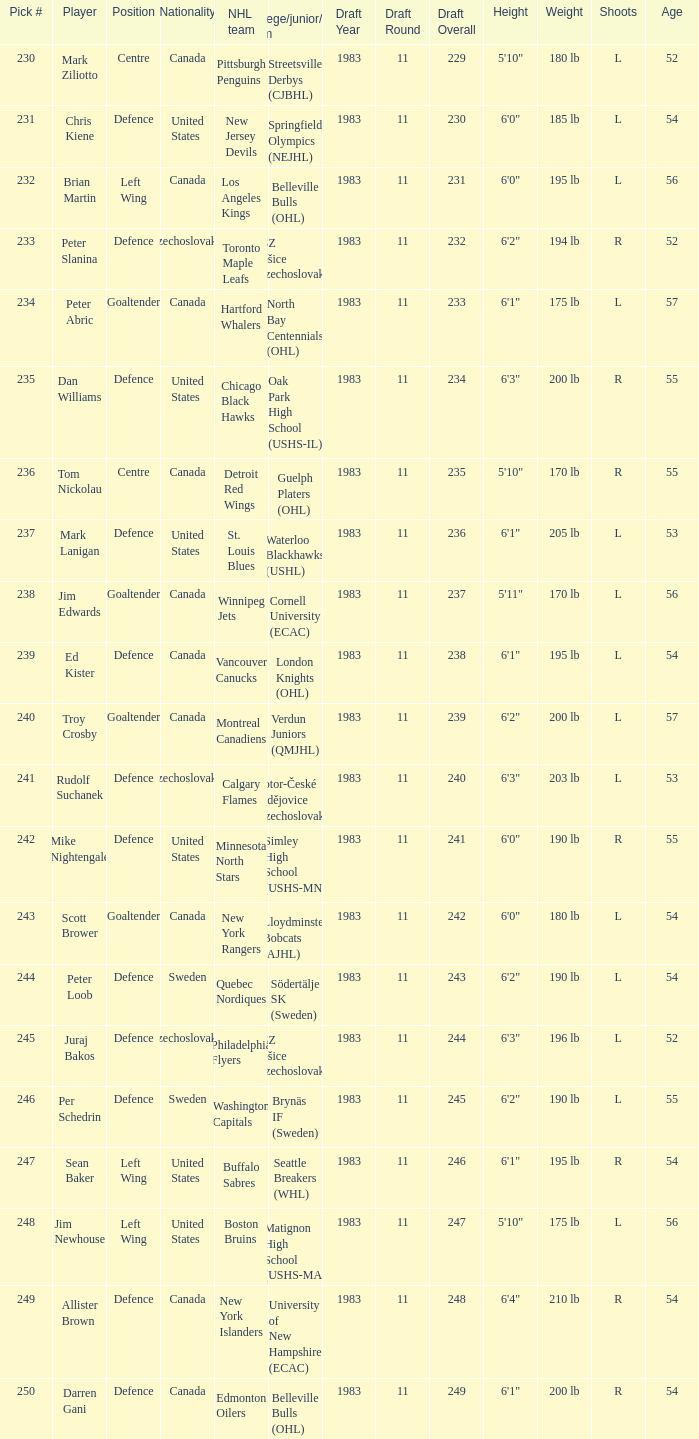Parse the full table. {'header': ['Pick #', 'Player', 'Position', 'Nationality', 'NHL team', 'College/junior/club team', 'Draft Year', 'Draft Round', 'Draft Overall', 'Height', 'Weight', 'Shoots', 'Age'], 'rows': [['230', 'Mark Ziliotto', 'Centre', 'Canada', 'Pittsburgh Penguins', 'Streetsville Derbys (CJBHL)', '1983', '11', '229', '5\'10"', '180 lb', 'L', '52'], ['231', 'Chris Kiene', 'Defence', 'United States', 'New Jersey Devils', 'Springfield Olympics (NEJHL)', '1983', '11', '230', '6\'0"', '185 lb', 'L', '54'], ['232', 'Brian Martin', 'Left Wing', 'Canada', 'Los Angeles Kings', 'Belleville Bulls (OHL)', '1983', '11', '231', '6\'0"', '195 lb', 'L', '56'], ['233', 'Peter Slanina', 'Defence', 'Czechoslovakia', 'Toronto Maple Leafs', 'VSZ Košice (Czechoslovakia)', '1983', '11', '232', '6\'2"', '194 lb', 'R', '52'], ['234', 'Peter Abric', 'Goaltender', 'Canada', 'Hartford Whalers', 'North Bay Centennials (OHL)', '1983', '11', '233', '6\'1"', '175 lb', 'L', '57'], ['235', 'Dan Williams', 'Defence', 'United States', 'Chicago Black Hawks', 'Oak Park High School (USHS-IL)', '1983', '11', '234', '6\'3"', '200 lb', 'R', '55'], ['236', 'Tom Nickolau', 'Centre', 'Canada', 'Detroit Red Wings', 'Guelph Platers (OHL)', '1983', '11', '235', '5\'10"', '170 lb', 'R', '55'], ['237', 'Mark Lanigan', 'Defence', 'United States', 'St. Louis Blues', 'Waterloo Blackhawks (USHL)', '1983', '11', '236', '6\'1"', '205 lb', 'L', '53'], ['238', 'Jim Edwards', 'Goaltender', 'Canada', 'Winnipeg Jets', 'Cornell University (ECAC)', '1983', '11', '237', '5\'11"', '170 lb', 'L', '56'], ['239', 'Ed Kister', 'Defence', 'Canada', 'Vancouver Canucks', 'London Knights (OHL)', '1983', '11', '238', '6\'1"', '195 lb', 'L', '54'], ['240', 'Troy Crosby', 'Goaltender', 'Canada', 'Montreal Canadiens', 'Verdun Juniors (QMJHL)', '1983', '11', '239', '6\'2"', '200 lb', 'L', '57'], ['241', 'Rudolf Suchanek', 'Defence', 'Czechoslovakia', 'Calgary Flames', 'Motor-České Budějovice (Czechoslovakia)', '1983', '11', '240', '6\'3"', '203 lb', 'L', '53'], ['242', 'Mike Nightengale', 'Defence', 'United States', 'Minnesota North Stars', 'Simley High School (USHS-MN)', '1983', '11', '241', '6\'0"', '190 lb', 'R', '55'], ['243', 'Scott Brower', 'Goaltender', 'Canada', 'New York Rangers', 'Lloydminster Bobcats (AJHL)', '1983', '11', '242', '6\'0"', '180 lb', 'L', '54'], ['244', 'Peter Loob', 'Defence', 'Sweden', 'Quebec Nordiques', 'Södertälje SK (Sweden)', '1983', '11', '243', '6\'2"', '190 lb', 'L', '54'], ['245', 'Juraj Bakos', 'Defence', 'Czechoslovakia', 'Philadelphia Flyers', 'VSZ Košice (Czechoslovakia)', '1983', '11', '244', '6\'3"', '196 lb', 'L', '52'], ['246', 'Per Schedrin', 'Defence', 'Sweden', 'Washington Capitals', 'Brynäs IF (Sweden)', '1983', '11', '245', '6\'2"', '190 lb', 'L', '55'], ['247', 'Sean Baker', 'Left Wing', 'United States', 'Buffalo Sabres', 'Seattle Breakers (WHL)', '1983', '11', '246', '6\'1"', '195 lb', 'R', '54'], ['248', 'Jim Newhouse', 'Left Wing', 'United States', 'Boston Bruins', 'Matignon High School (USHS-MA)', '1983', '11', '247', '5\'10"', '175 lb', 'L', '56'], ['249', 'Allister Brown', 'Defence', 'Canada', 'New York Islanders', 'University of New Hampshire (ECAC)', '1983', '11', '248', '6\'4"', '210 lb', 'R', '54'], ['250', 'Darren Gani', 'Defence', 'Canada', 'Edmonton Oilers', 'Belleville Bulls (OHL)', '1983', '11', '249', '6\'1"', '200 lb', 'R', '54']]} What selection was the springfield olympics (nejhl)? 231.0. 